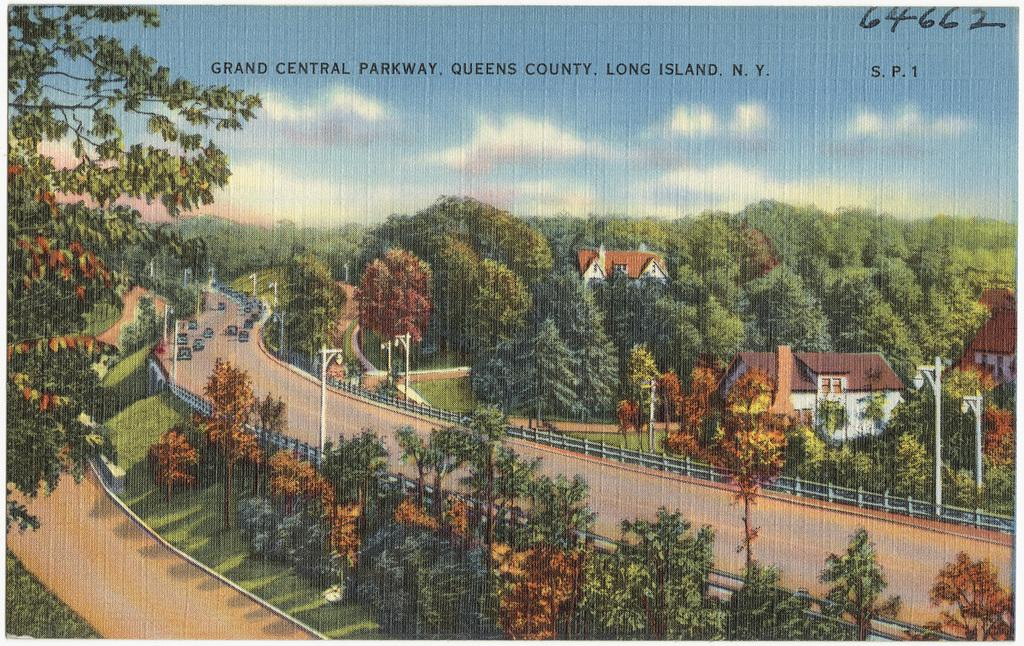What type of artwork is depicted in the image? The image is a painting. What type of natural elements can be seen in the painting? There are trees in the image. What type of man-made structures are present in the painting? There are roads and houses in the image. What part of the natural environment is visible in the painting? The sky is visible at the top of the image. What color is used for a specific element in the painting? There is a matter in black color in the image. Where is the library located in the painting? There is no library present in the painting; it features trees, roads, houses, and a black matter. What type of mint can be seen growing near the houses in the painting? There is no mint present in the painting; it only includes trees, roads, houses, and a black matter. 